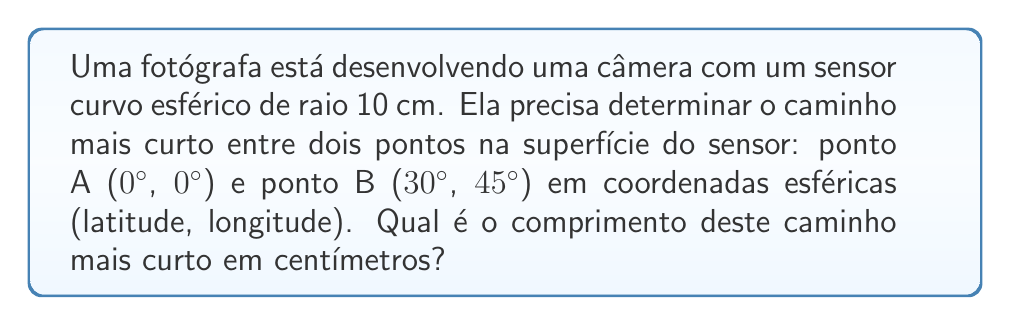Could you help me with this problem? Para resolver este problema, seguiremos estes passos:

1) Em uma esfera, o caminho mais curto entre dois pontos é um arco de círculo máximo.

2) O comprimento deste arco é dado por $$ d = R \theta $$, onde $R$ é o raio da esfera e $\theta$ é o ângulo central em radianos.

3) Para encontrar $\theta$, usamos a fórmula do cosseno esférico:

   $$ \cos(\theta) = \sin(\phi_1)\sin(\phi_2) + \cos(\phi_1)\cos(\phi_2)\cos(\Delta \lambda) $$

   onde $\phi_1$ e $\phi_2$ são as latitudes, e $\Delta \lambda$ é a diferença de longitude.

4) Convertendo para radianos:
   $\phi_1 = 0°$ = 0 rad
   $\phi_2 = 30°$ = $\frac{\pi}{6}$ rad
   $\Delta \lambda = 45°$ = $\frac{\pi}{4}$ rad

5) Substituindo na fórmula:

   $$ \cos(\theta) = \sin(0)\sin(\frac{\pi}{6}) + \cos(0)\cos(\frac{\pi}{6})\cos(\frac{\pi}{4}) $$

6) Simplificando:

   $$ \cos(\theta) = 0 + \cos(\frac{\pi}{6})\cos(\frac{\pi}{4}) = \frac{\sqrt{3}}{2} \cdot \frac{\sqrt{2}}{2} = \frac{\sqrt{6}}{4} $$

7) Resolvendo para $\theta$:

   $$ \theta = \arccos(\frac{\sqrt{6}}{4}) \approx 0.8410 \text{ rad} $$

8) Calculando o comprimento do arco:

   $$ d = R \theta = 10 \cdot 0.8410 \approx 8.410 \text{ cm} $$
Answer: 8.410 cm 